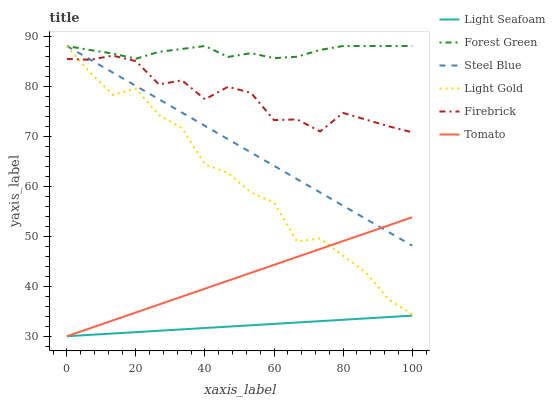Does Light Seafoam have the minimum area under the curve?
Answer yes or no. Yes. Does Forest Green have the maximum area under the curve?
Answer yes or no. Yes. Does Firebrick have the minimum area under the curve?
Answer yes or no. No. Does Firebrick have the maximum area under the curve?
Answer yes or no. No. Is Light Seafoam the smoothest?
Answer yes or no. Yes. Is Light Gold the roughest?
Answer yes or no. Yes. Is Firebrick the smoothest?
Answer yes or no. No. Is Firebrick the roughest?
Answer yes or no. No. Does Tomato have the lowest value?
Answer yes or no. Yes. Does Firebrick have the lowest value?
Answer yes or no. No. Does Light Gold have the highest value?
Answer yes or no. Yes. Does Firebrick have the highest value?
Answer yes or no. No. Is Tomato less than Forest Green?
Answer yes or no. Yes. Is Firebrick greater than Tomato?
Answer yes or no. Yes. Does Light Gold intersect Tomato?
Answer yes or no. Yes. Is Light Gold less than Tomato?
Answer yes or no. No. Is Light Gold greater than Tomato?
Answer yes or no. No. Does Tomato intersect Forest Green?
Answer yes or no. No. 